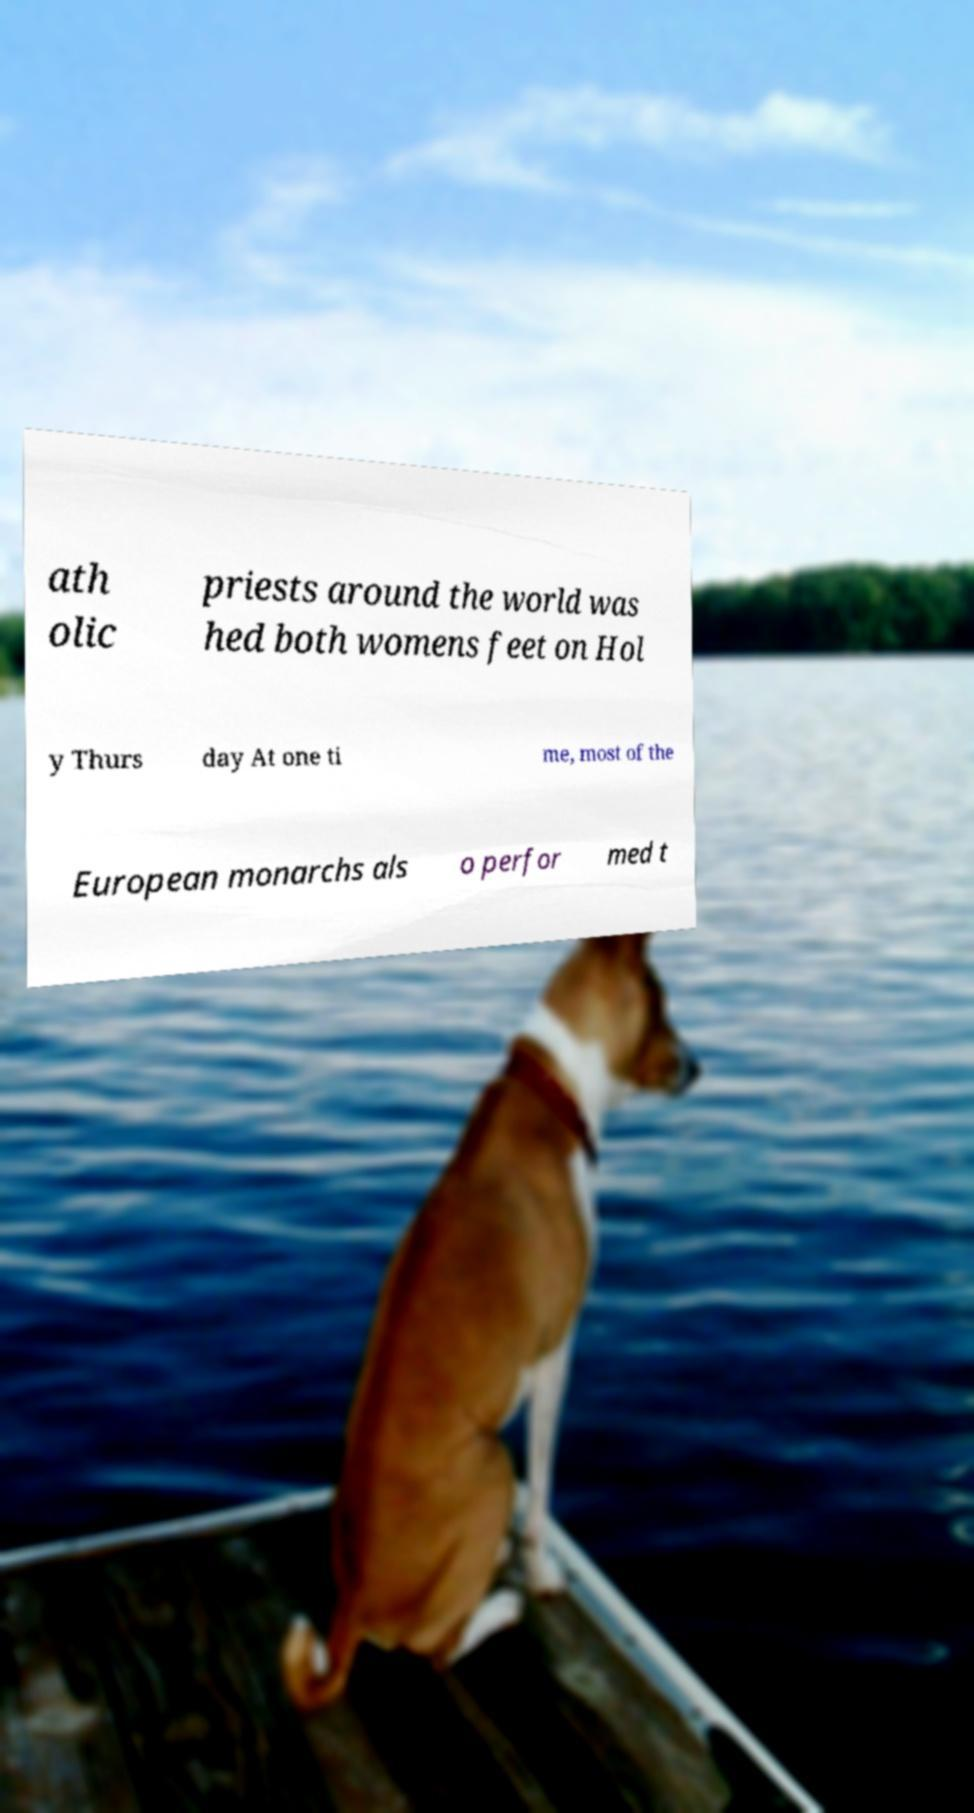Can you read and provide the text displayed in the image?This photo seems to have some interesting text. Can you extract and type it out for me? ath olic priests around the world was hed both womens feet on Hol y Thurs day At one ti me, most of the European monarchs als o perfor med t 